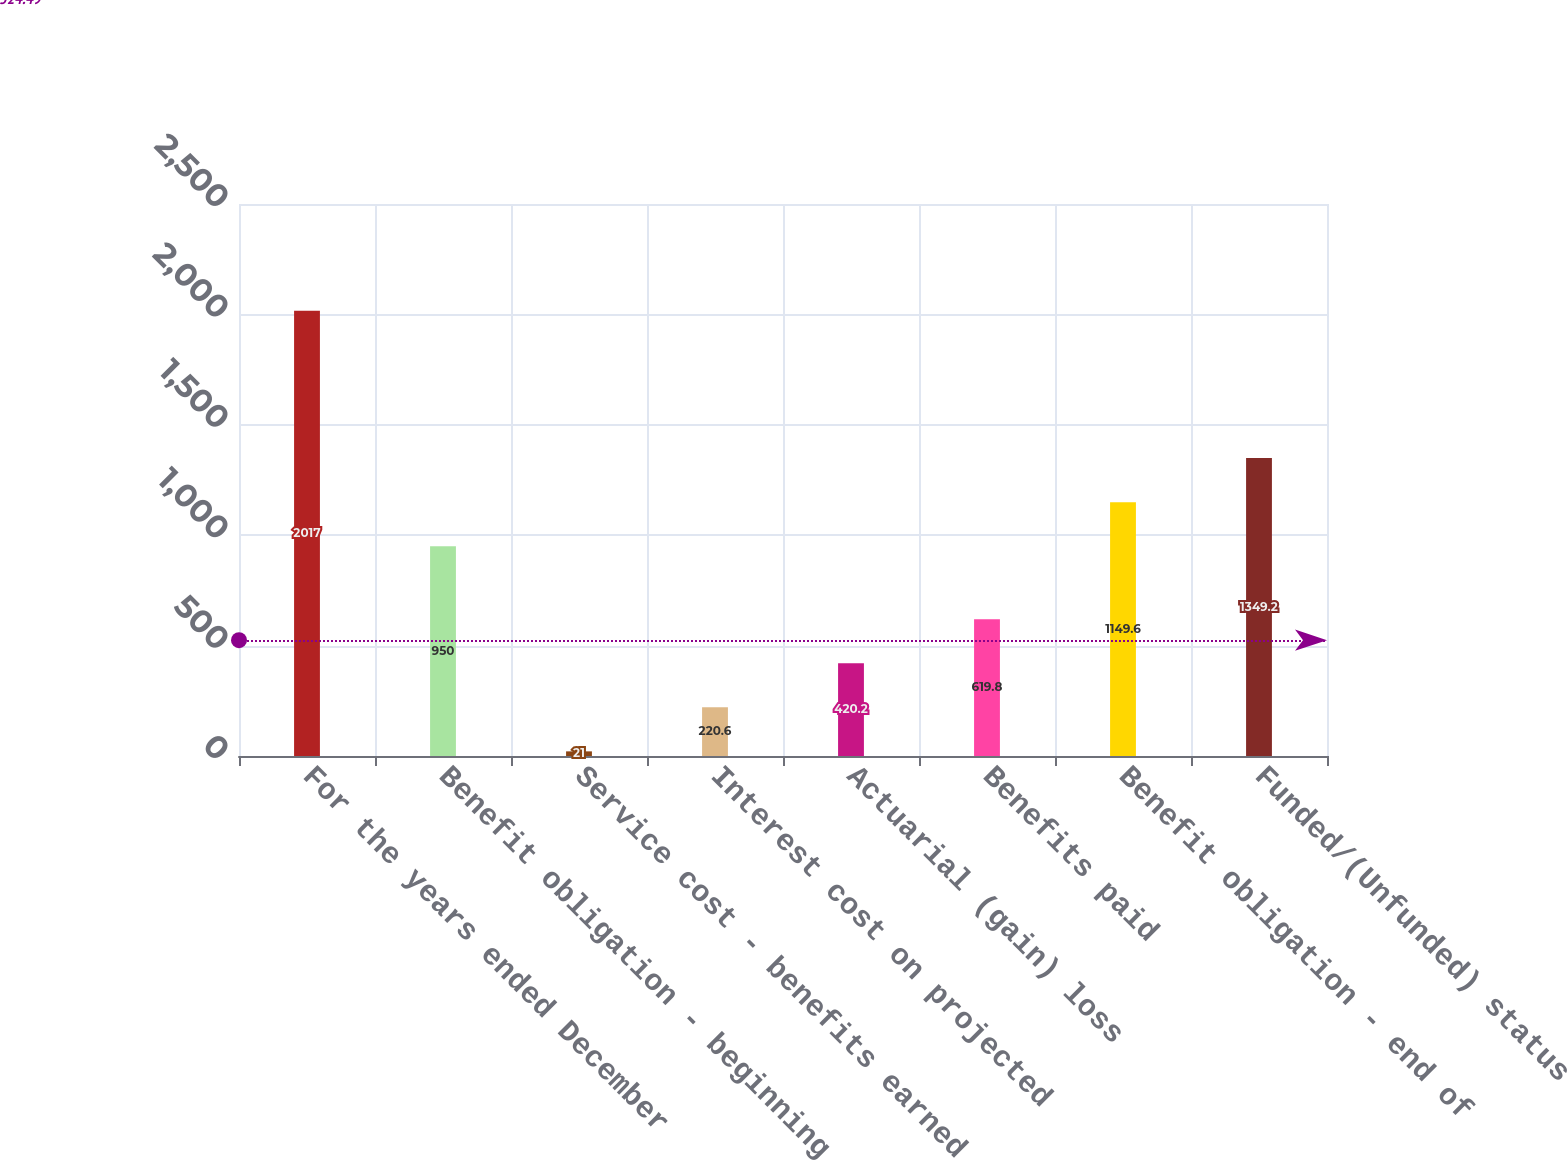Convert chart. <chart><loc_0><loc_0><loc_500><loc_500><bar_chart><fcel>For the years ended December<fcel>Benefit obligation - beginning<fcel>Service cost - benefits earned<fcel>Interest cost on projected<fcel>Actuarial (gain) loss<fcel>Benefits paid<fcel>Benefit obligation - end of<fcel>Funded/(Unfunded) status<nl><fcel>2017<fcel>950<fcel>21<fcel>220.6<fcel>420.2<fcel>619.8<fcel>1149.6<fcel>1349.2<nl></chart> 